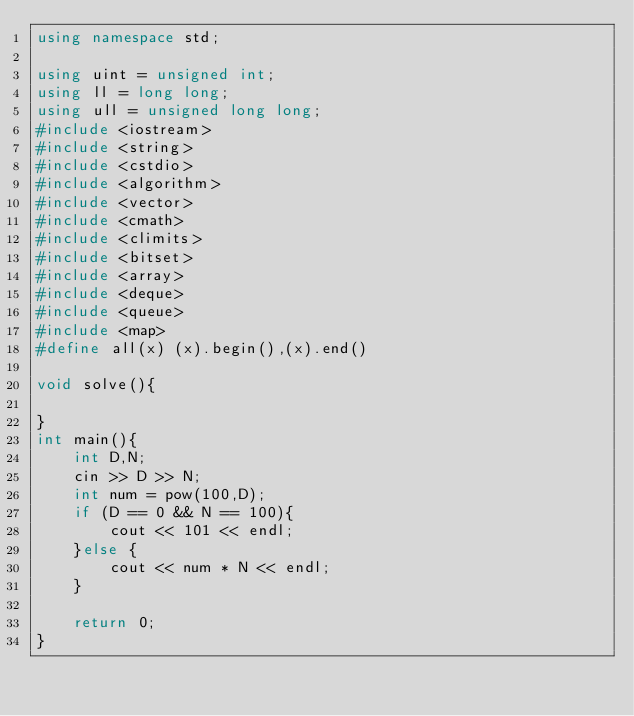<code> <loc_0><loc_0><loc_500><loc_500><_C++_>using namespace std;

using uint = unsigned int;
using ll = long long;
using ull = unsigned long long;
#include <iostream>
#include <string>
#include <cstdio>
#include <algorithm>
#include <vector>
#include <cmath>
#include <climits>
#include <bitset>
#include <array>
#include <deque>
#include <queue>
#include <map>
#define all(x) (x).begin(),(x).end()

void solve(){

}
int main(){
    int D,N;
    cin >> D >> N;
    int num = pow(100,D);
    if (D == 0 && N == 100){
        cout << 101 << endl;
    }else {
        cout << num * N << endl;
    }

    return 0;
}
</code> 